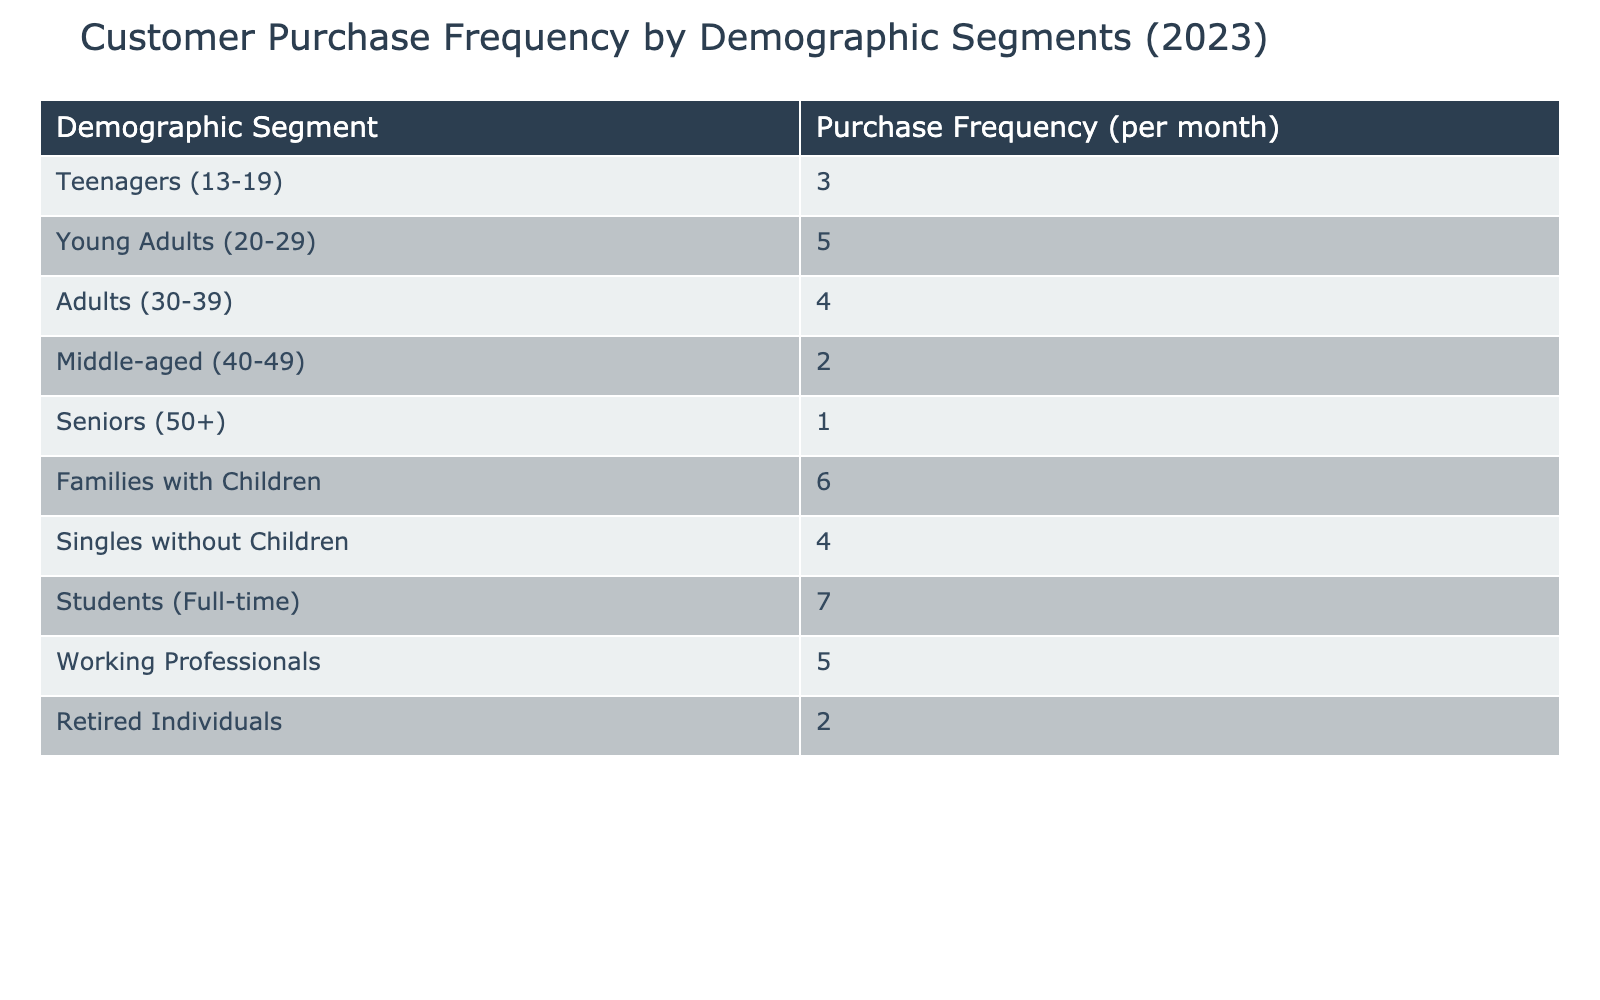What is the purchase frequency for Families with Children? The table shows that Families with Children have a purchase frequency of 6 per month, directly listed in the relevant row.
Answer: 6 Which demographic segment has the highest purchase frequency? By reviewing the purchase frequencies for all segments, Families with Children have the highest frequency of 6 per month, which is more than any other segment.
Answer: Families with Children What is the average purchase frequency for students and teenagers combined? To find the average, first, we sum the purchase frequencies: Students have 7 and Teenagers have 3, giving us (7 + 3) = 10. Since there are 2 segments, the average is 10/2 = 5.
Answer: 5 Do adults have a higher purchase frequency than seniors? The purchase frequency for Adults is 4 per month, while for Seniors it is 1 per month. Since 4 is greater than 1, we can conclude that Adults have a higher frequency.
Answer: Yes What is the total purchase frequency for all demographic segments listed in the table? Adding up all the purchase frequencies: 3 + 5 + 4 + 2 + 1 + 6 + 4 + 7 + 5 + 2 = 39. This gives us the total purchase frequency across all segments.
Answer: 39 How many segments have a purchase frequency of 4 or more? Listing the segments with frequencies of 4 or more: Young Adults (5), Adults (4), Families with Children (6), Students (7), and Working Professionals (5). This totals to 5 segments that meet the criteria.
Answer: 5 Is it true that the purchase frequency for Working Professionals is equal to that of Adults? The purchase frequency for Working Professionals is 5, while for Adults it is 4. Since 5 is not equal to 4, the statement is false.
Answer: No Which demographic segment has the lowest purchase frequency, and what is that frequency? The demographic segment with the lowest frequency is Seniors with a purchase frequency of 1 per month, explicitly listed in the table.
Answer: Seniors, 1 What is the difference in purchase frequency between Families with Children and Middle-aged individuals? Families with Children have a purchase frequency of 6, while Middle-aged individuals have 2. The difference is calculated as 6 - 2 = 4.
Answer: 4 